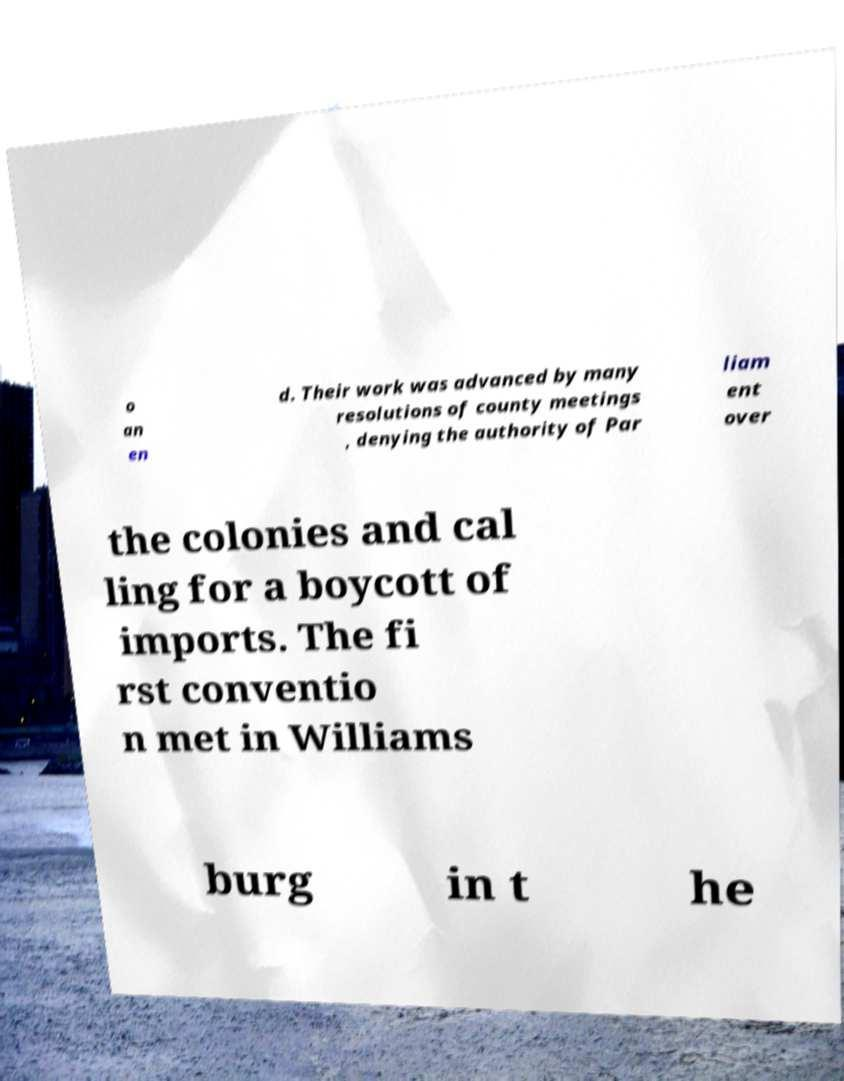Could you extract and type out the text from this image? o an en d. Their work was advanced by many resolutions of county meetings , denying the authority of Par liam ent over the colonies and cal ling for a boycott of imports. The fi rst conventio n met in Williams burg in t he 